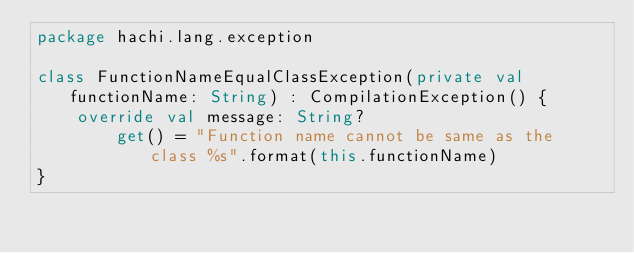<code> <loc_0><loc_0><loc_500><loc_500><_Kotlin_>package hachi.lang.exception

class FunctionNameEqualClassException(private val functionName: String) : CompilationException() {
    override val message: String?
        get() = "Function name cannot be same as the class %s".format(this.functionName)
}</code> 